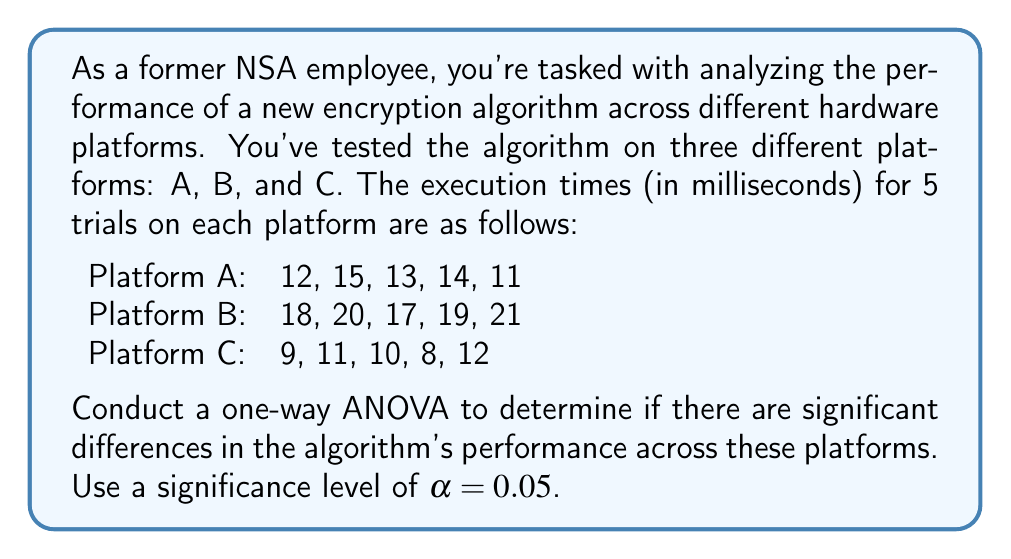Teach me how to tackle this problem. To conduct a one-way ANOVA, we'll follow these steps:

1. Calculate the sum of squares between groups (SSB), within groups (SSW), and total (SST).
2. Calculate the degrees of freedom for between groups (dfB), within groups (dfW), and total (dfT).
3. Calculate the mean square between groups (MSB) and within groups (MSW).
4. Calculate the F-statistic.
5. Compare the F-statistic to the critical F-value.

Step 1: Calculate sum of squares

First, we need to calculate the grand mean:
$$ \bar{X} = \frac{12+15+13+14+11+18+20+17+19+21+9+11+10+8+12}{15} = 14 $$

Now, we can calculate SSB, SSW, and SST:

SSB:
$$ SSB = 5[(13-14)^2 + (19-14)^2 + (10-14)^2] = 250 $$

SSW:
$$ SSW = [(12-13)^2 + (15-13)^2 + (13-13)^2 + (14-13)^2 + (11-13)^2] + $$
$$ [(18-19)^2 + (20-19)^2 + (17-19)^2 + (19-19)^2 + (21-19)^2] + $$
$$ [(9-10)^2 + (11-10)^2 + (10-10)^2 + (8-10)^2 + (12-10)^2] = 46 $$

SST:
$$ SST = SSB + SSW = 250 + 46 = 296 $$

Step 2: Calculate degrees of freedom

dfB = number of groups - 1 = 3 - 1 = 2
dfW = total number of observations - number of groups = 15 - 3 = 12
dfT = total number of observations - 1 = 15 - 1 = 14

Step 3: Calculate mean squares

$$ MSB = \frac{SSB}{dfB} = \frac{250}{2} = 125 $$
$$ MSW = \frac{SSW}{dfW} = \frac{46}{12} = 3.83 $$

Step 4: Calculate F-statistic

$$ F = \frac{MSB}{MSW} = \frac{125}{3.83} = 32.64 $$

Step 5: Compare F-statistic to critical F-value

The critical F-value for α = 0.05, dfB = 2, and dfW = 12 is approximately 3.89.

Since our calculated F-statistic (32.64) is greater than the critical F-value (3.89), we reject the null hypothesis.
Answer: The one-way ANOVA results in an F-statistic of 32.64, which is greater than the critical F-value of 3.89 at α = 0.05. Therefore, we reject the null hypothesis and conclude that there are significant differences in the encryption algorithm's performance across the three hardware platforms. 